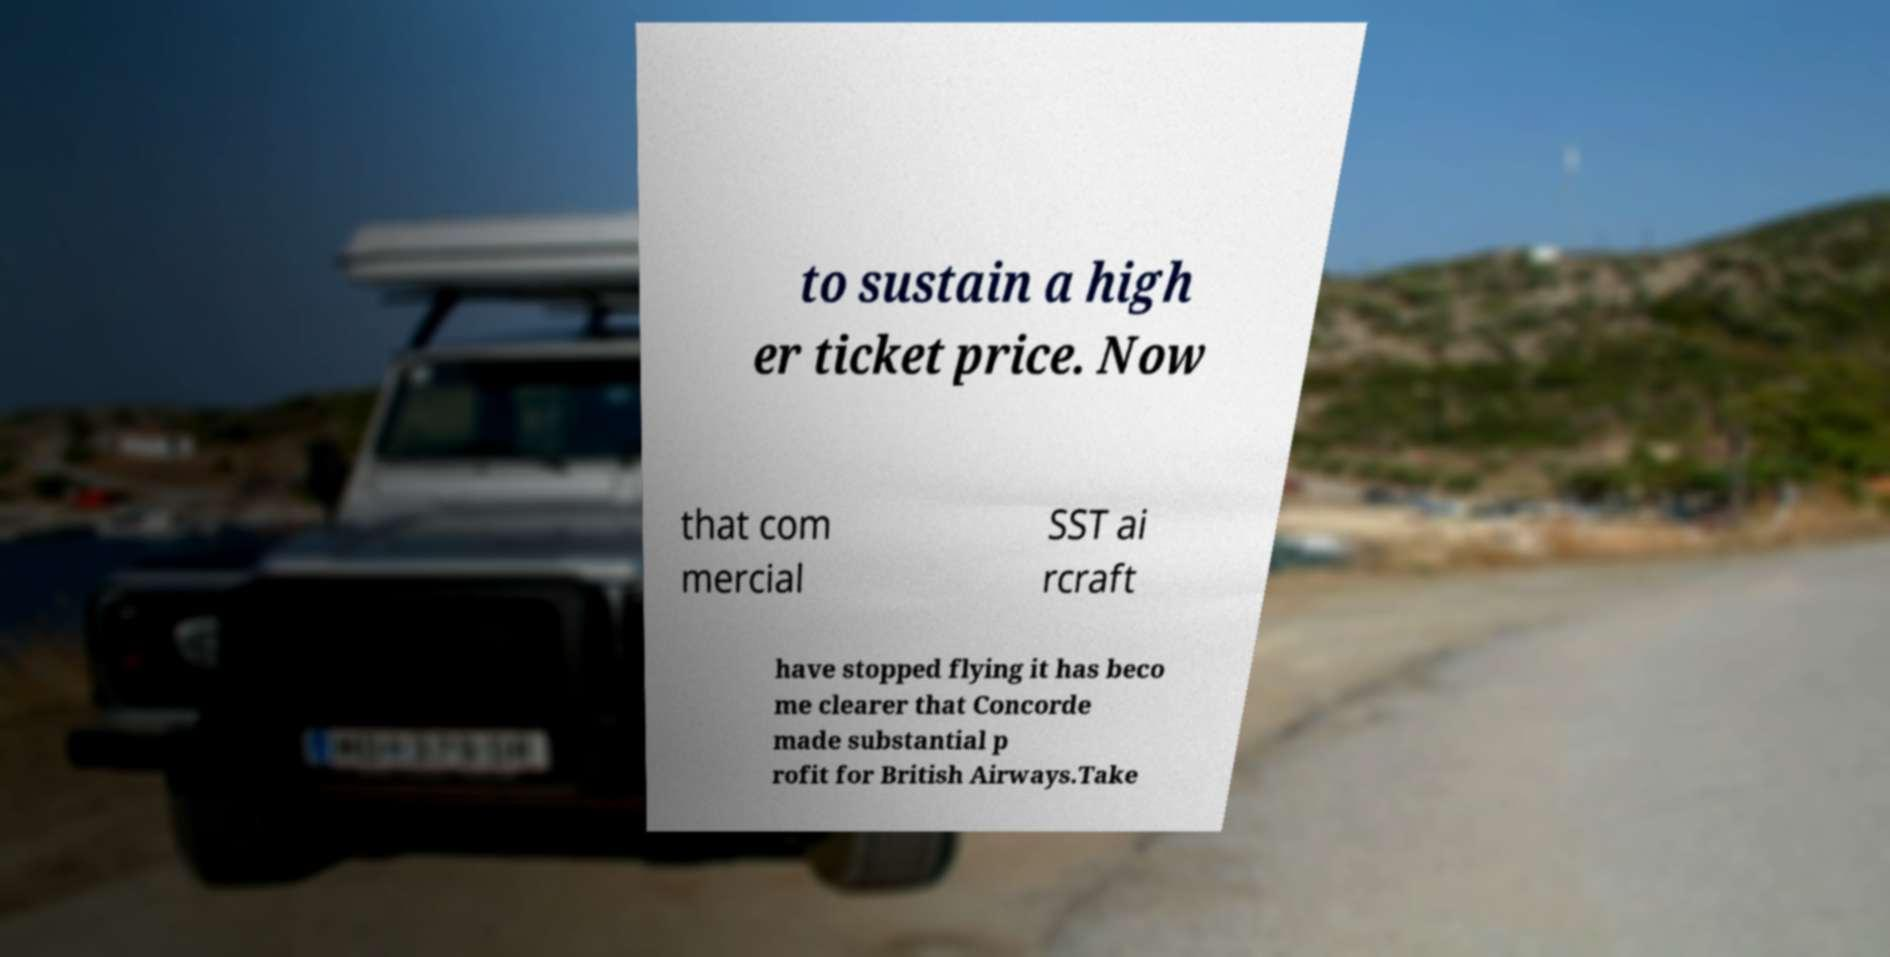Please read and relay the text visible in this image. What does it say? to sustain a high er ticket price. Now that com mercial SST ai rcraft have stopped flying it has beco me clearer that Concorde made substantial p rofit for British Airways.Take 